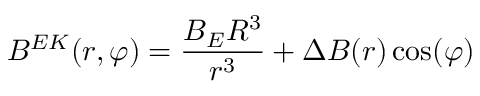Convert formula to latex. <formula><loc_0><loc_0><loc_500><loc_500>B ^ { E K } ( r , \varphi ) = \frac { B _ { E } R ^ { 3 } } { r ^ { 3 } } + \Delta B ( r ) \cos ( \varphi )</formula> 